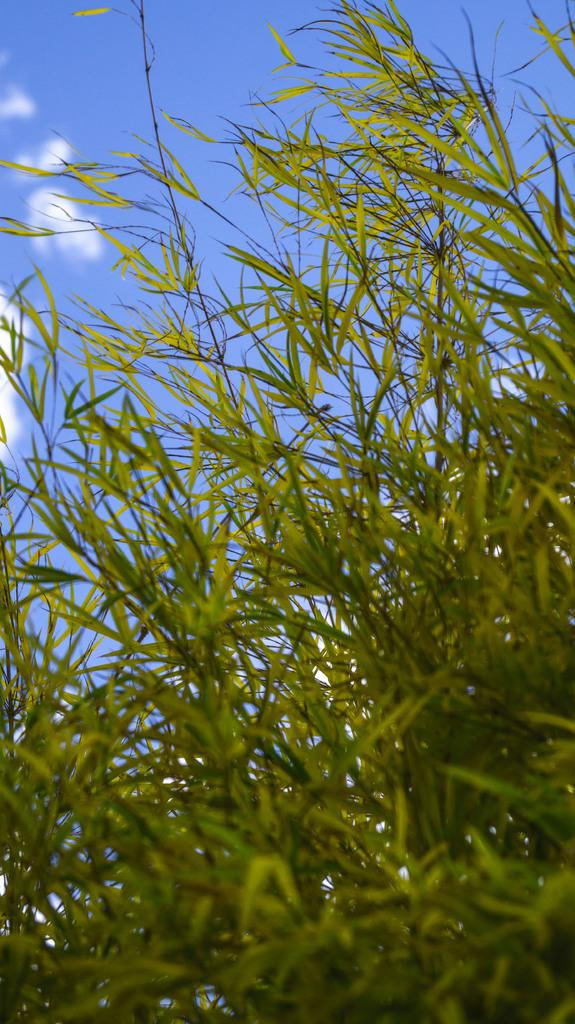What type of vegetation is present in the image? There is grass in the image. What color is the sky in the image? The sky is blue in the image. Are there any ghosts visible in the image? There are no ghosts present in the image. What type of road can be seen in the image? There is no road visible in the image; it only features grass and a blue sky. 